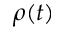<formula> <loc_0><loc_0><loc_500><loc_500>\rho ( t )</formula> 